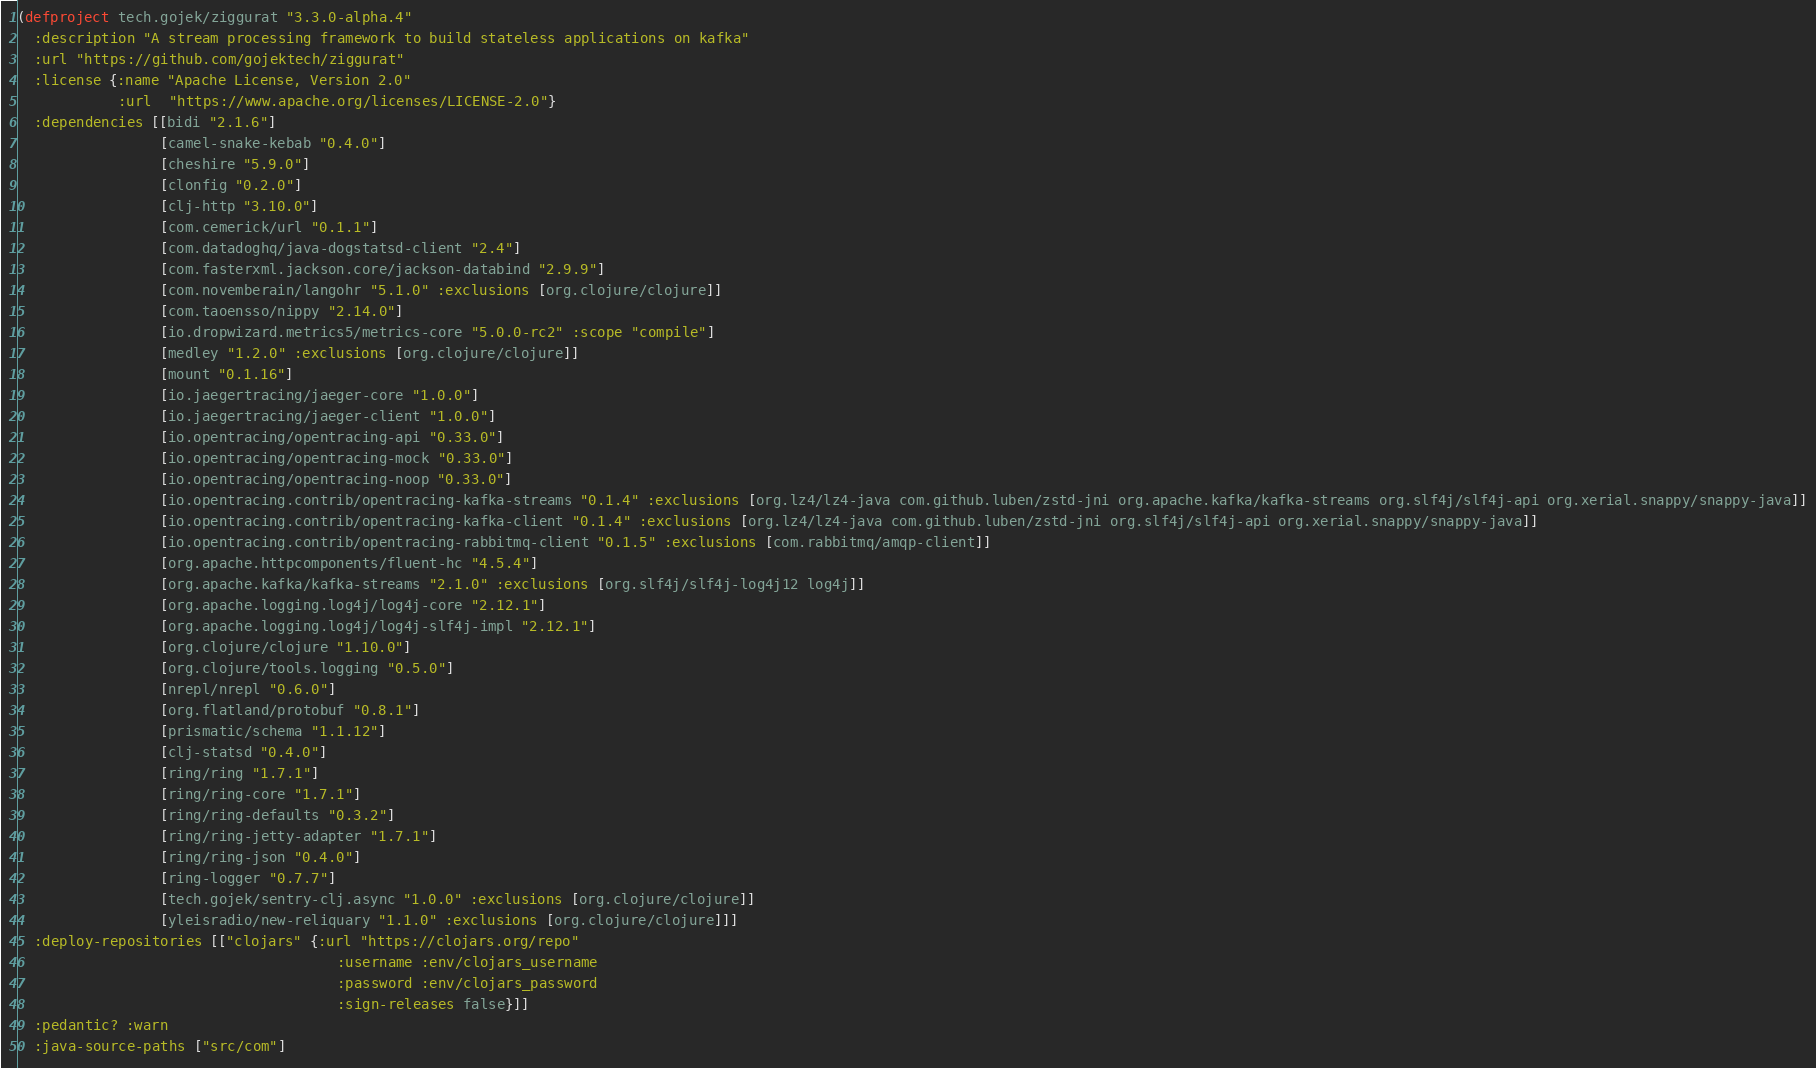<code> <loc_0><loc_0><loc_500><loc_500><_Clojure_>(defproject tech.gojek/ziggurat "3.3.0-alpha.4"
  :description "A stream processing framework to build stateless applications on kafka"
  :url "https://github.com/gojektech/ziggurat"
  :license {:name "Apache License, Version 2.0"
            :url  "https://www.apache.org/licenses/LICENSE-2.0"}
  :dependencies [[bidi "2.1.6"]
                 [camel-snake-kebab "0.4.0"]
                 [cheshire "5.9.0"]
                 [clonfig "0.2.0"]
                 [clj-http "3.10.0"]
                 [com.cemerick/url "0.1.1"]
                 [com.datadoghq/java-dogstatsd-client "2.4"]
                 [com.fasterxml.jackson.core/jackson-databind "2.9.9"]
                 [com.novemberain/langohr "5.1.0" :exclusions [org.clojure/clojure]]
                 [com.taoensso/nippy "2.14.0"]
                 [io.dropwizard.metrics5/metrics-core "5.0.0-rc2" :scope "compile"]
                 [medley "1.2.0" :exclusions [org.clojure/clojure]]
                 [mount "0.1.16"]
                 [io.jaegertracing/jaeger-core "1.0.0"]
                 [io.jaegertracing/jaeger-client "1.0.0"]
                 [io.opentracing/opentracing-api "0.33.0"]
                 [io.opentracing/opentracing-mock "0.33.0"]
                 [io.opentracing/opentracing-noop "0.33.0"]
                 [io.opentracing.contrib/opentracing-kafka-streams "0.1.4" :exclusions [org.lz4/lz4-java com.github.luben/zstd-jni org.apache.kafka/kafka-streams org.slf4j/slf4j-api org.xerial.snappy/snappy-java]]
                 [io.opentracing.contrib/opentracing-kafka-client "0.1.4" :exclusions [org.lz4/lz4-java com.github.luben/zstd-jni org.slf4j/slf4j-api org.xerial.snappy/snappy-java]]
                 [io.opentracing.contrib/opentracing-rabbitmq-client "0.1.5" :exclusions [com.rabbitmq/amqp-client]]
                 [org.apache.httpcomponents/fluent-hc "4.5.4"]
                 [org.apache.kafka/kafka-streams "2.1.0" :exclusions [org.slf4j/slf4j-log4j12 log4j]]
                 [org.apache.logging.log4j/log4j-core "2.12.1"]
                 [org.apache.logging.log4j/log4j-slf4j-impl "2.12.1"]
                 [org.clojure/clojure "1.10.0"]
                 [org.clojure/tools.logging "0.5.0"]
                 [nrepl/nrepl "0.6.0"]
                 [org.flatland/protobuf "0.8.1"]
                 [prismatic/schema "1.1.12"]
                 [clj-statsd "0.4.0"]
                 [ring/ring "1.7.1"]
                 [ring/ring-core "1.7.1"]
                 [ring/ring-defaults "0.3.2"]
                 [ring/ring-jetty-adapter "1.7.1"]
                 [ring/ring-json "0.4.0"]
                 [ring-logger "0.7.7"]
                 [tech.gojek/sentry-clj.async "1.0.0" :exclusions [org.clojure/clojure]]
                 [yleisradio/new-reliquary "1.1.0" :exclusions [org.clojure/clojure]]]
  :deploy-repositories [["clojars" {:url "https://clojars.org/repo"
                                      :username :env/clojars_username
                                      :password :env/clojars_password
                                      :sign-releases false}]]
  :pedantic? :warn
  :java-source-paths ["src/com"]</code> 